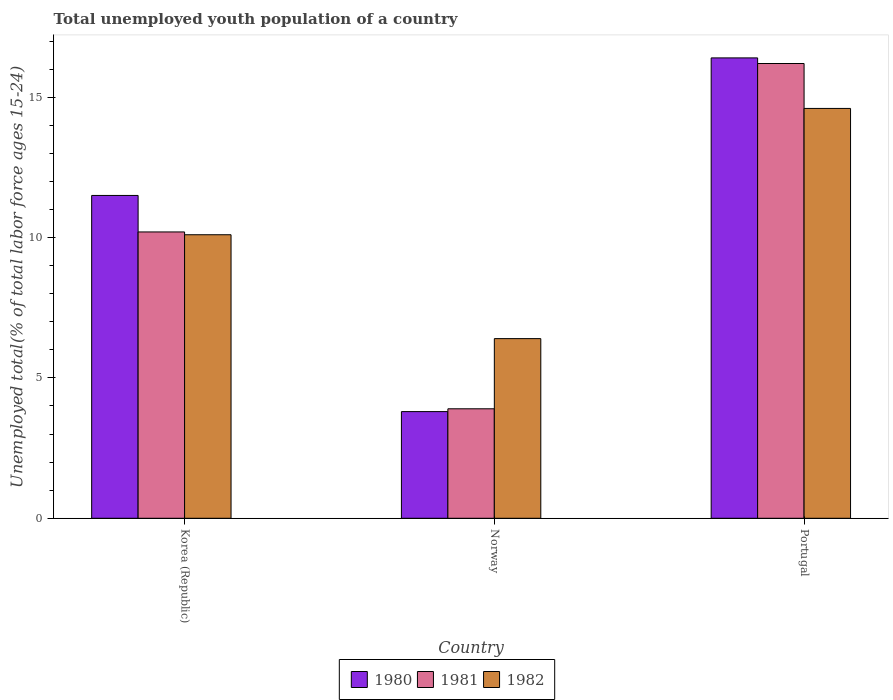How many different coloured bars are there?
Provide a short and direct response. 3. How many groups of bars are there?
Keep it short and to the point. 3. What is the label of the 1st group of bars from the left?
Your answer should be compact. Korea (Republic). What is the percentage of total unemployed youth population of a country in 1982 in Norway?
Give a very brief answer. 6.4. Across all countries, what is the maximum percentage of total unemployed youth population of a country in 1980?
Give a very brief answer. 16.4. Across all countries, what is the minimum percentage of total unemployed youth population of a country in 1982?
Provide a short and direct response. 6.4. In which country was the percentage of total unemployed youth population of a country in 1980 minimum?
Provide a short and direct response. Norway. What is the total percentage of total unemployed youth population of a country in 1981 in the graph?
Provide a short and direct response. 30.3. What is the difference between the percentage of total unemployed youth population of a country in 1981 in Korea (Republic) and that in Norway?
Your answer should be very brief. 6.3. What is the difference between the percentage of total unemployed youth population of a country in 1982 in Portugal and the percentage of total unemployed youth population of a country in 1981 in Korea (Republic)?
Offer a very short reply. 4.4. What is the average percentage of total unemployed youth population of a country in 1982 per country?
Your answer should be compact. 10.37. What is the difference between the percentage of total unemployed youth population of a country of/in 1980 and percentage of total unemployed youth population of a country of/in 1981 in Korea (Republic)?
Ensure brevity in your answer.  1.3. In how many countries, is the percentage of total unemployed youth population of a country in 1980 greater than 15 %?
Give a very brief answer. 1. What is the ratio of the percentage of total unemployed youth population of a country in 1982 in Norway to that in Portugal?
Provide a short and direct response. 0.44. What is the difference between the highest and the second highest percentage of total unemployed youth population of a country in 1980?
Provide a succinct answer. 12.6. What is the difference between the highest and the lowest percentage of total unemployed youth population of a country in 1982?
Your answer should be very brief. 8.2. Is the sum of the percentage of total unemployed youth population of a country in 1981 in Norway and Portugal greater than the maximum percentage of total unemployed youth population of a country in 1980 across all countries?
Offer a very short reply. Yes. What does the 3rd bar from the right in Portugal represents?
Offer a very short reply. 1980. Is it the case that in every country, the sum of the percentage of total unemployed youth population of a country in 1982 and percentage of total unemployed youth population of a country in 1981 is greater than the percentage of total unemployed youth population of a country in 1980?
Your response must be concise. Yes. How many bars are there?
Give a very brief answer. 9. Are all the bars in the graph horizontal?
Offer a very short reply. No. Does the graph contain grids?
Provide a succinct answer. No. How are the legend labels stacked?
Give a very brief answer. Horizontal. What is the title of the graph?
Your response must be concise. Total unemployed youth population of a country. What is the label or title of the Y-axis?
Offer a very short reply. Unemployed total(% of total labor force ages 15-24). What is the Unemployed total(% of total labor force ages 15-24) in 1980 in Korea (Republic)?
Provide a succinct answer. 11.5. What is the Unemployed total(% of total labor force ages 15-24) of 1981 in Korea (Republic)?
Keep it short and to the point. 10.2. What is the Unemployed total(% of total labor force ages 15-24) in 1982 in Korea (Republic)?
Give a very brief answer. 10.1. What is the Unemployed total(% of total labor force ages 15-24) of 1980 in Norway?
Provide a succinct answer. 3.8. What is the Unemployed total(% of total labor force ages 15-24) in 1981 in Norway?
Offer a very short reply. 3.9. What is the Unemployed total(% of total labor force ages 15-24) in 1982 in Norway?
Your response must be concise. 6.4. What is the Unemployed total(% of total labor force ages 15-24) of 1980 in Portugal?
Provide a short and direct response. 16.4. What is the Unemployed total(% of total labor force ages 15-24) in 1981 in Portugal?
Give a very brief answer. 16.2. What is the Unemployed total(% of total labor force ages 15-24) of 1982 in Portugal?
Provide a succinct answer. 14.6. Across all countries, what is the maximum Unemployed total(% of total labor force ages 15-24) in 1980?
Give a very brief answer. 16.4. Across all countries, what is the maximum Unemployed total(% of total labor force ages 15-24) of 1981?
Keep it short and to the point. 16.2. Across all countries, what is the maximum Unemployed total(% of total labor force ages 15-24) in 1982?
Ensure brevity in your answer.  14.6. Across all countries, what is the minimum Unemployed total(% of total labor force ages 15-24) of 1980?
Offer a very short reply. 3.8. Across all countries, what is the minimum Unemployed total(% of total labor force ages 15-24) in 1981?
Provide a succinct answer. 3.9. Across all countries, what is the minimum Unemployed total(% of total labor force ages 15-24) in 1982?
Your answer should be compact. 6.4. What is the total Unemployed total(% of total labor force ages 15-24) in 1980 in the graph?
Your response must be concise. 31.7. What is the total Unemployed total(% of total labor force ages 15-24) in 1981 in the graph?
Your answer should be very brief. 30.3. What is the total Unemployed total(% of total labor force ages 15-24) in 1982 in the graph?
Ensure brevity in your answer.  31.1. What is the difference between the Unemployed total(% of total labor force ages 15-24) of 1980 in Korea (Republic) and that in Norway?
Offer a very short reply. 7.7. What is the difference between the Unemployed total(% of total labor force ages 15-24) of 1981 in Korea (Republic) and that in Norway?
Your answer should be compact. 6.3. What is the difference between the Unemployed total(% of total labor force ages 15-24) in 1982 in Korea (Republic) and that in Portugal?
Keep it short and to the point. -4.5. What is the difference between the Unemployed total(% of total labor force ages 15-24) of 1980 in Korea (Republic) and the Unemployed total(% of total labor force ages 15-24) of 1981 in Norway?
Your response must be concise. 7.6. What is the difference between the Unemployed total(% of total labor force ages 15-24) in 1980 in Korea (Republic) and the Unemployed total(% of total labor force ages 15-24) in 1981 in Portugal?
Provide a succinct answer. -4.7. What is the difference between the Unemployed total(% of total labor force ages 15-24) of 1980 in Korea (Republic) and the Unemployed total(% of total labor force ages 15-24) of 1982 in Portugal?
Your answer should be compact. -3.1. What is the difference between the Unemployed total(% of total labor force ages 15-24) of 1981 in Korea (Republic) and the Unemployed total(% of total labor force ages 15-24) of 1982 in Portugal?
Ensure brevity in your answer.  -4.4. What is the average Unemployed total(% of total labor force ages 15-24) in 1980 per country?
Offer a very short reply. 10.57. What is the average Unemployed total(% of total labor force ages 15-24) in 1982 per country?
Provide a succinct answer. 10.37. What is the difference between the Unemployed total(% of total labor force ages 15-24) of 1980 and Unemployed total(% of total labor force ages 15-24) of 1981 in Korea (Republic)?
Keep it short and to the point. 1.3. What is the difference between the Unemployed total(% of total labor force ages 15-24) of 1981 and Unemployed total(% of total labor force ages 15-24) of 1982 in Korea (Republic)?
Your answer should be very brief. 0.1. What is the difference between the Unemployed total(% of total labor force ages 15-24) of 1980 and Unemployed total(% of total labor force ages 15-24) of 1981 in Norway?
Provide a succinct answer. -0.1. What is the difference between the Unemployed total(% of total labor force ages 15-24) in 1980 and Unemployed total(% of total labor force ages 15-24) in 1982 in Portugal?
Provide a short and direct response. 1.8. What is the difference between the Unemployed total(% of total labor force ages 15-24) in 1981 and Unemployed total(% of total labor force ages 15-24) in 1982 in Portugal?
Offer a terse response. 1.6. What is the ratio of the Unemployed total(% of total labor force ages 15-24) of 1980 in Korea (Republic) to that in Norway?
Give a very brief answer. 3.03. What is the ratio of the Unemployed total(% of total labor force ages 15-24) of 1981 in Korea (Republic) to that in Norway?
Your answer should be compact. 2.62. What is the ratio of the Unemployed total(% of total labor force ages 15-24) in 1982 in Korea (Republic) to that in Norway?
Ensure brevity in your answer.  1.58. What is the ratio of the Unemployed total(% of total labor force ages 15-24) in 1980 in Korea (Republic) to that in Portugal?
Keep it short and to the point. 0.7. What is the ratio of the Unemployed total(% of total labor force ages 15-24) in 1981 in Korea (Republic) to that in Portugal?
Ensure brevity in your answer.  0.63. What is the ratio of the Unemployed total(% of total labor force ages 15-24) in 1982 in Korea (Republic) to that in Portugal?
Ensure brevity in your answer.  0.69. What is the ratio of the Unemployed total(% of total labor force ages 15-24) of 1980 in Norway to that in Portugal?
Make the answer very short. 0.23. What is the ratio of the Unemployed total(% of total labor force ages 15-24) of 1981 in Norway to that in Portugal?
Offer a terse response. 0.24. What is the ratio of the Unemployed total(% of total labor force ages 15-24) of 1982 in Norway to that in Portugal?
Provide a succinct answer. 0.44. What is the difference between the highest and the second highest Unemployed total(% of total labor force ages 15-24) of 1980?
Keep it short and to the point. 4.9. What is the difference between the highest and the second highest Unemployed total(% of total labor force ages 15-24) of 1981?
Give a very brief answer. 6. What is the difference between the highest and the lowest Unemployed total(% of total labor force ages 15-24) of 1980?
Offer a very short reply. 12.6. What is the difference between the highest and the lowest Unemployed total(% of total labor force ages 15-24) in 1982?
Your answer should be compact. 8.2. 